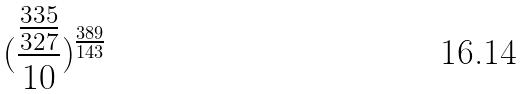Convert formula to latex. <formula><loc_0><loc_0><loc_500><loc_500>( \frac { \frac { 3 3 5 } { 3 2 7 } } { 1 0 } ) ^ { \frac { 3 8 9 } { 1 4 3 } }</formula> 